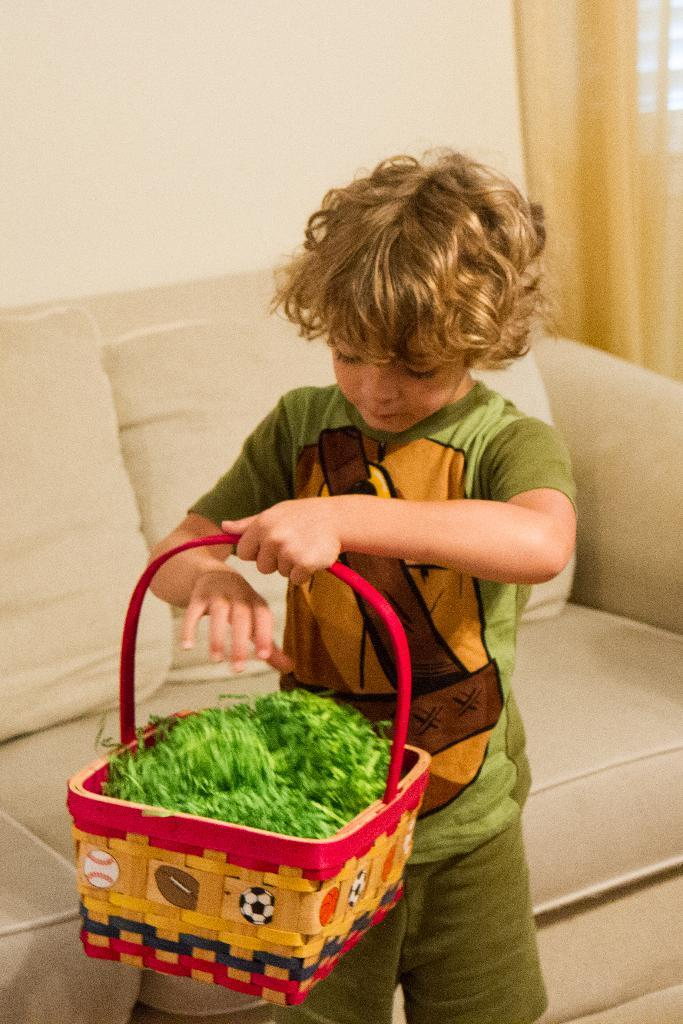What is the boy in the image doing? The boy is standing in the image and holding a basket with green vegetables. What is in the basket that the boy is holding? The basket contains green vegetables. What type of furniture is visible in the image? There are pillows on a sofa in the image. What can be seen in the background of the image? There is a wall and a curtain in the background of the image. What religion is being practiced in the image? There is no indication of any religious practice in the image. How many chairs are visible in the image? There are no chairs visible in the image. 